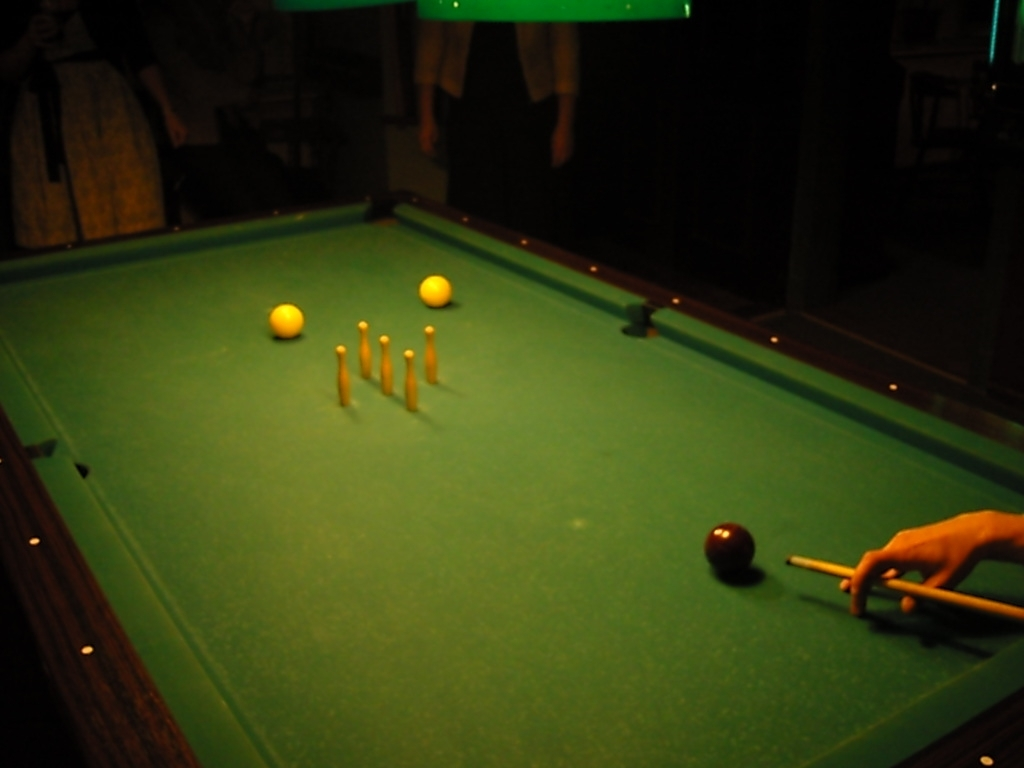What type of game is being played on the pool table? The game set up on the table appears to be a form of billiards, possibly carom billiards, as evidenced by the absence of pockets on the table and the use of two cue balls along with a single object ball. 